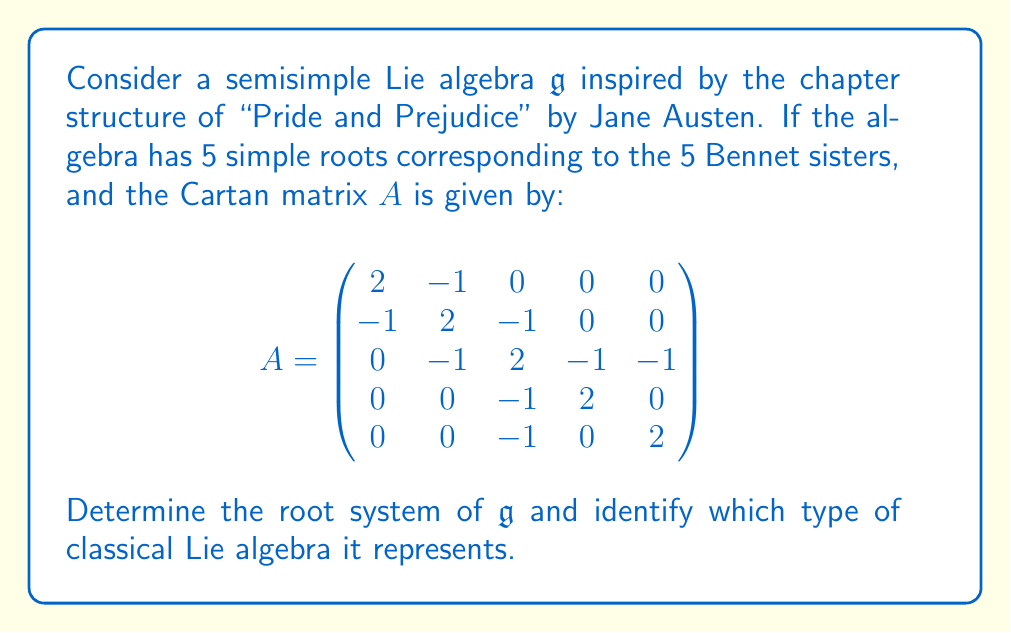Teach me how to tackle this problem. To solve this problem, we'll follow these steps:

1) First, we need to identify the Dynkin diagram from the Cartan matrix. The Cartan matrix gives us information about how the simple roots are connected.

2) From the Cartan matrix, we can see that:
   - $\alpha_1$ is connected to $\alpha_2$
   - $\alpha_2$ is connected to $\alpha_3$
   - $\alpha_3$ is connected to $\alpha_4$ and $\alpha_5$
   - $\alpha_4$ and $\alpha_5$ are not connected to each other

3) This gives us the following Dynkin diagram:

[asy]
unitsize(1cm);
dot((0,0)); dot((1,0)); dot((2,0)); dot((3,1)); dot((3,-1));
draw((0,0)--(2,0));
draw((2,0)--(3,1));
draw((2,0)--(3,-1));
label("$\alpha_1$", (0,0), W);
label("$\alpha_2$", (1,0), S);
label("$\alpha_3$", (2,0), S);
label("$\alpha_4$", (3,1), E);
label("$\alpha_5$", (3,-1), E);
[/asy]

4) This Dynkin diagram corresponds to the Lie algebra of type $D_5$.

5) The root system of $D_5$ consists of the following roots:
   - 20 positive roots:
     $\{\alpha_i, \alpha_i + \alpha_j, \alpha_i + \alpha_j + \alpha_k, \alpha_i + \alpha_j + \alpha_k + \alpha_l, \alpha_1 + \alpha_2 + \alpha_3 + \alpha_4 + \alpha_5\}$
     where $i < j < k < l$
   - 20 negative roots (the negatives of the positive roots)
   - 5 simple roots $\{\alpha_1, \alpha_2, \alpha_3, \alpha_4, \alpha_5\}$

6) In total, there are 40 roots plus the 0 root, making 41 roots in the root system.

7) The highest root is $\alpha_1 + \alpha_2 + \alpha_3 + \alpha_4 + \alpha_5$.

Therefore, this Lie algebra corresponds to the classical Lie algebra $\mathfrak{so}(10)$, which is the special orthogonal Lie algebra in 10 dimensions.
Answer: The root system of $\mathfrak{g}$ corresponds to the $D_5$ Dynkin diagram, which represents the classical Lie algebra $\mathfrak{so}(10)$. It has 41 roots in total: 20 positive roots, 20 negative roots, and the 0 root. 